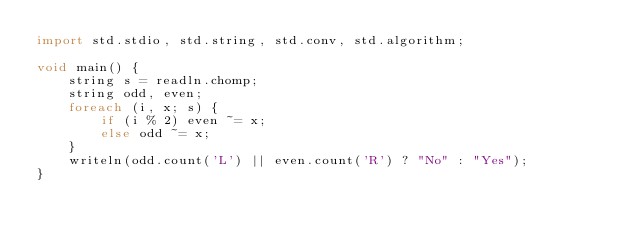<code> <loc_0><loc_0><loc_500><loc_500><_D_>import std.stdio, std.string, std.conv, std.algorithm;

void main() {
    string s = readln.chomp;
    string odd, even;
    foreach (i, x; s) {
        if (i % 2) even ~= x;
        else odd ~= x;
    }
    writeln(odd.count('L') || even.count('R') ? "No" : "Yes");
}</code> 